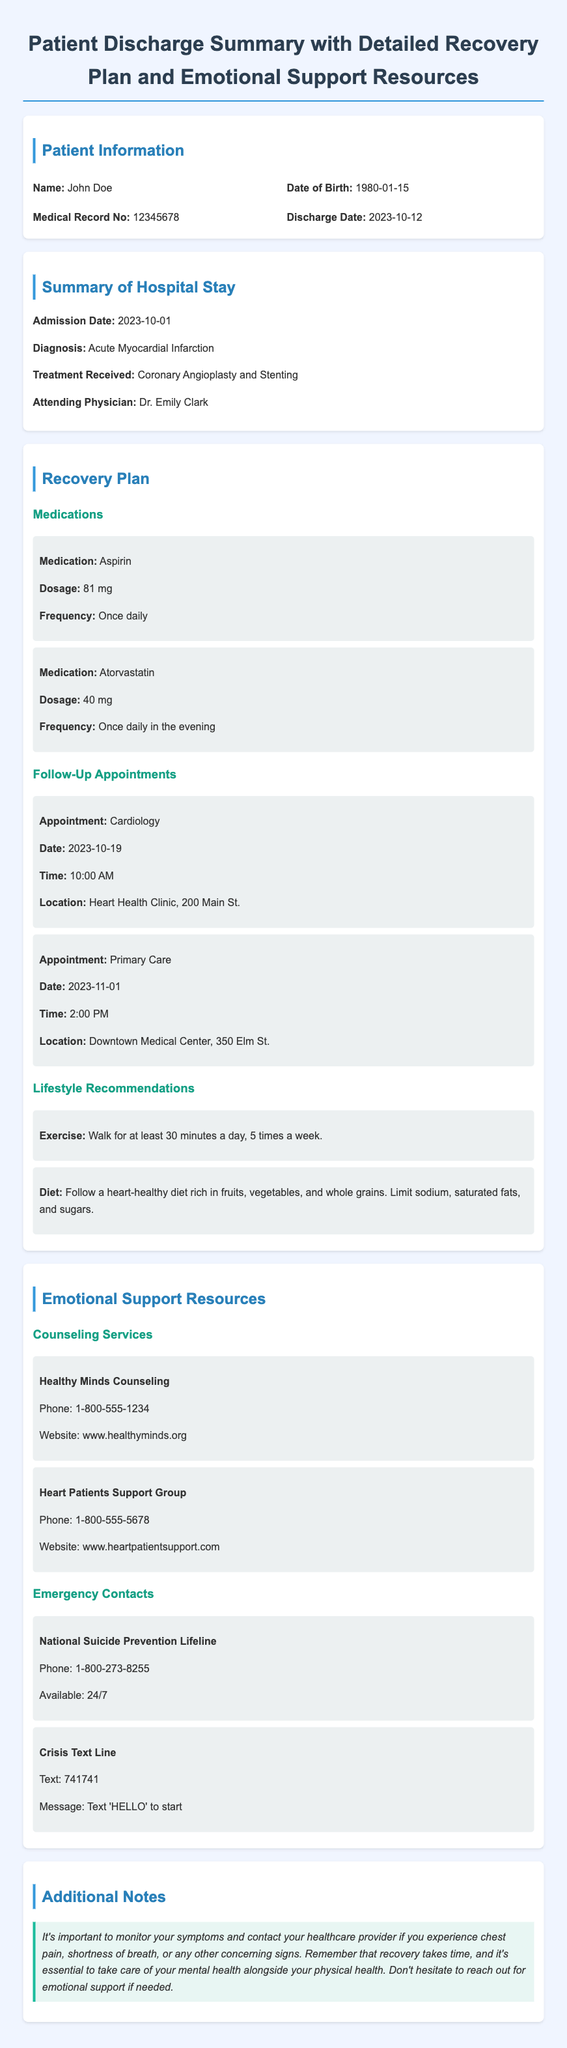What is the patient's name? The patient's name is mentioned in the patient information section of the document.
Answer: John Doe What is the discharge date? The discharge date is listed in the patient information section.
Answer: 2023-10-12 What type of treatment did the patient receive? The treatment received by the patient is described in the summary of the hospital stay section.
Answer: Coronary Angioplasty and Stenting When is the next cardiology appointment? The date of the next cardiology appointment is provided in the recovery plan section.
Answer: 2023-10-19 What is one lifestyle recommendation for the patient? The lifestyle recommendations section provides guidance on healthy practices for recovery.
Answer: Walk for at least 30 minutes a day, 5 times a week Which organization offers counseling services? The emotional support resources section lists available counseling services.
Answer: Healthy Minds Counseling What is the phone number for the National Suicide Prevention Lifeline? This information is available in the emergency contacts section.
Answer: 1-800-273-8255 Why is it important to monitor symptoms post-discharge? The additional notes section emphasizes the significance of symptom monitoring.
Answer: It's important to monitor your symptoms and contact your healthcare provider What should the patient do if they experience concerning signs? The additional notes section includes advice for handling concerning symptoms.
Answer: Contact your healthcare provider 